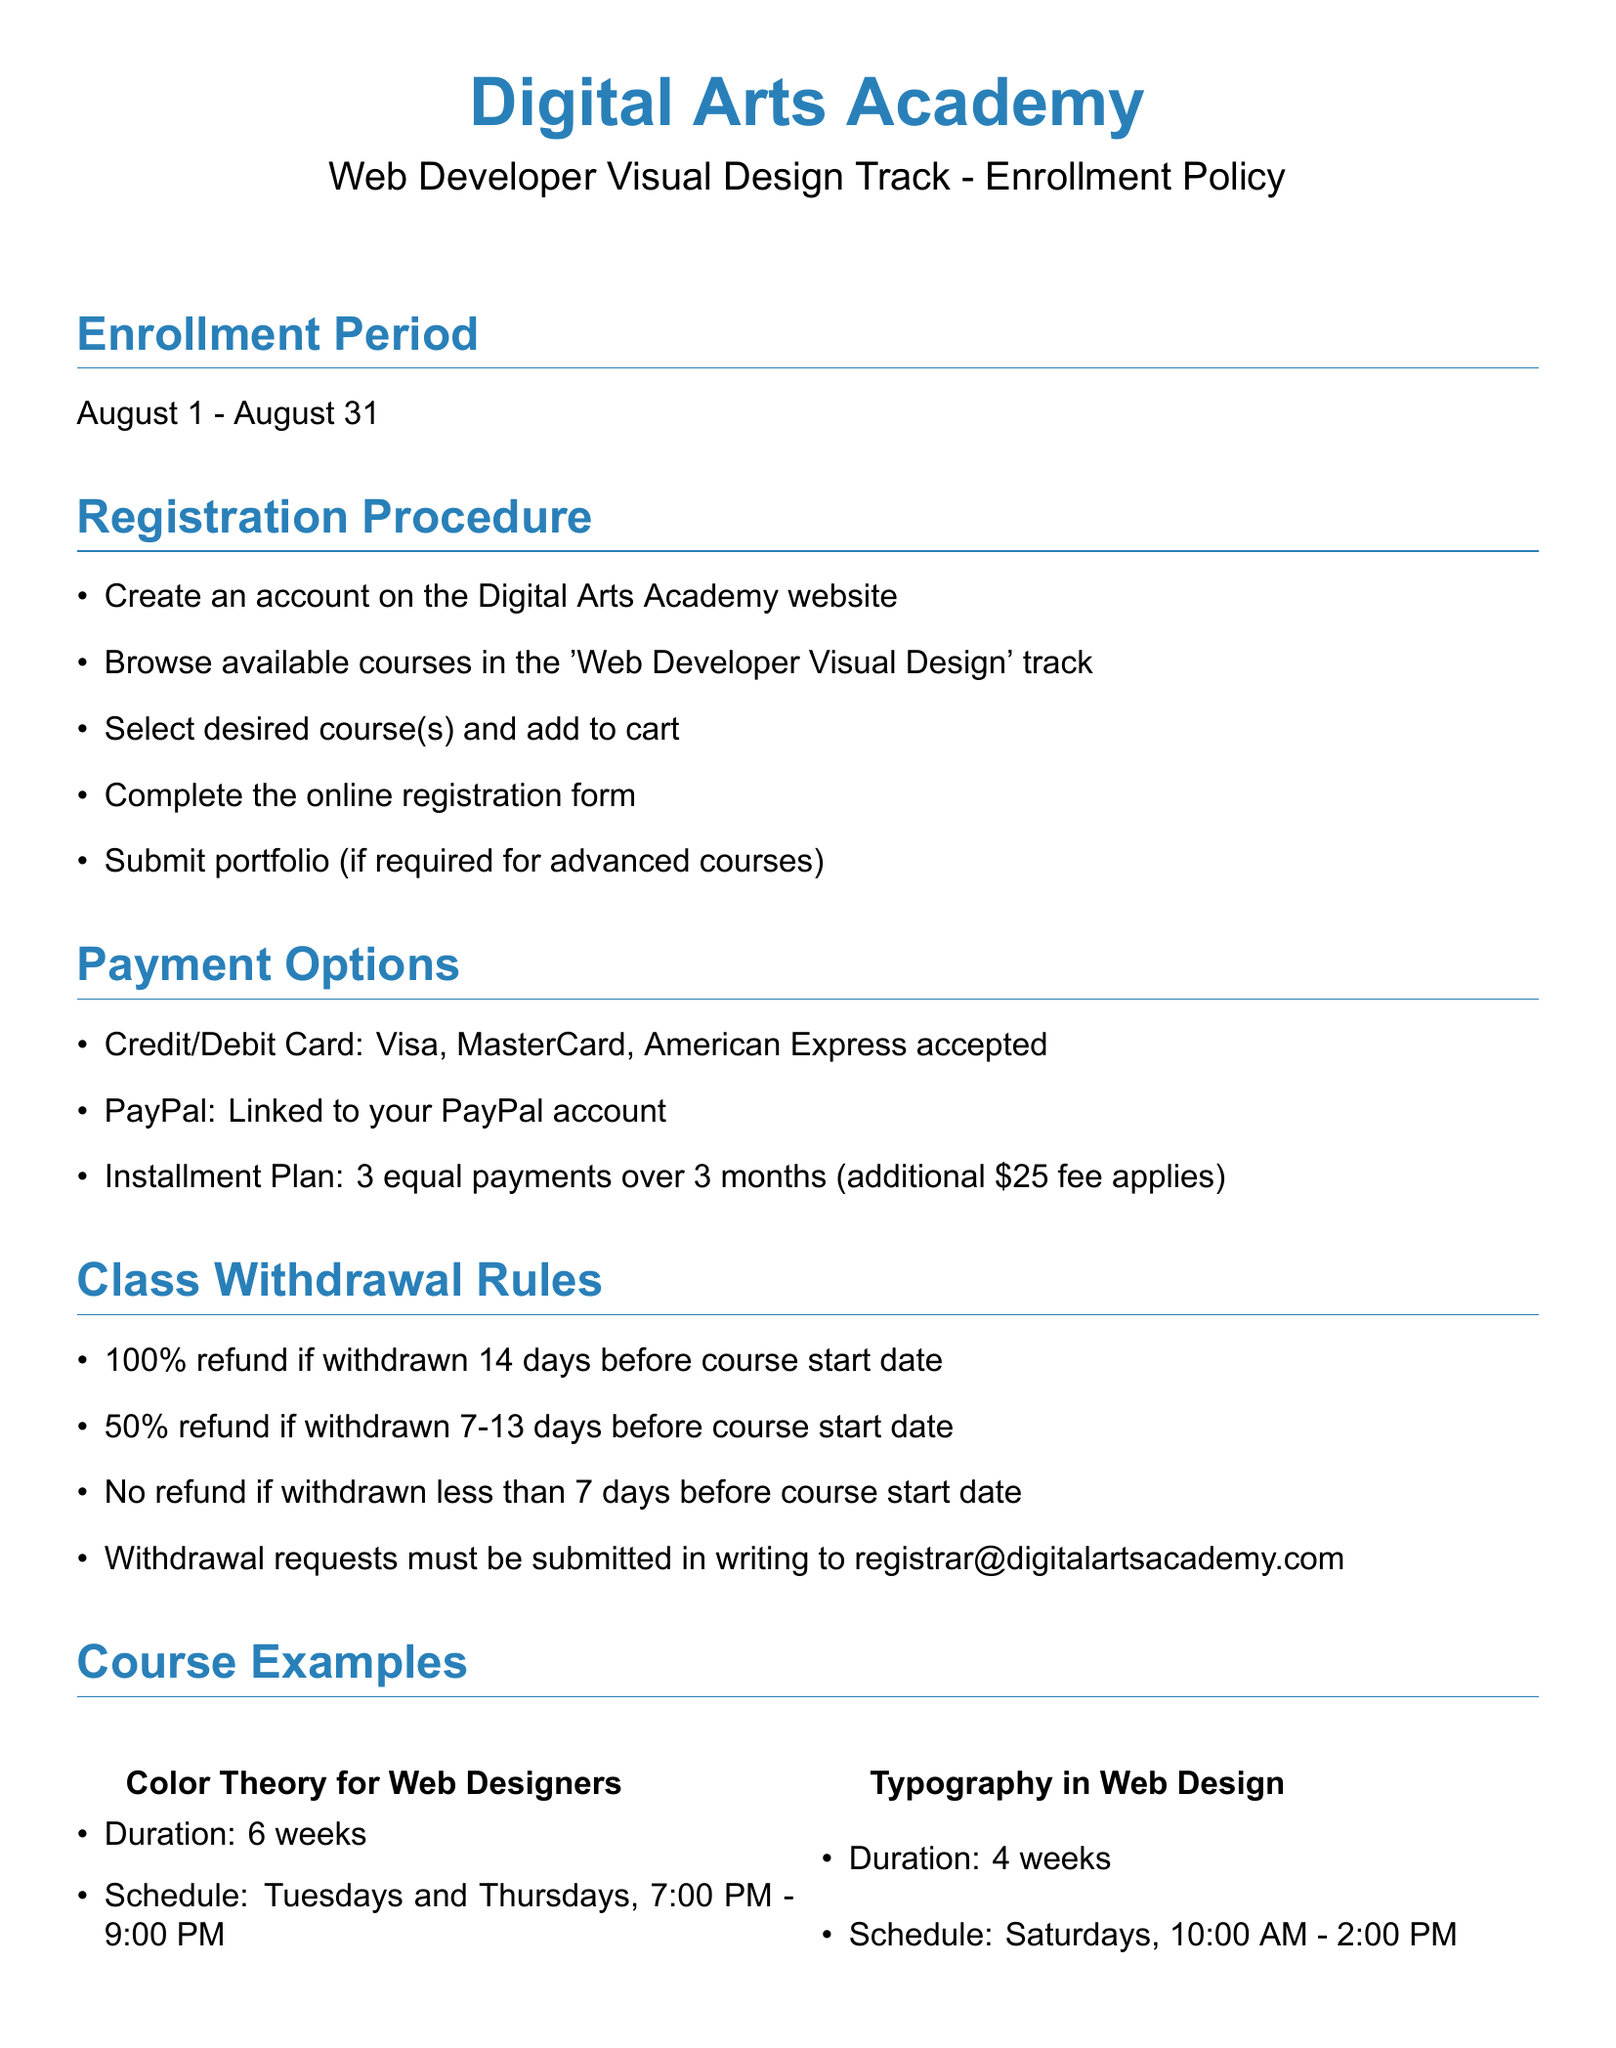What is the enrollment period? The enrollment period is clearly stated in the document, which is from August 1 to August 31.
Answer: August 1 - August 31 What payment option incurs an additional fee? The payment option for installments mentions an additional fee of $25, as noted in the document.
Answer: Installment Plan How many weeks is the "Color Theory for Web Designers" course? The duration of the "Color Theory for Web Designers" course is specified in the course examples section.
Answer: 6 weeks What percentage of the refund is available for withdrawal less than 7 days before the course starts? The document outlines the refund percentages based on withdrawal timing, stating no refund for withdrawals under 7 days.
Answer: No refund Where can withdrawal requests be submitted? The document specifies the contact method for withdrawal requests, which must be in writing sent to a particular email address.
Answer: registrar@digitalartsacademy.com How many courses are listed as examples in the document? The document contains two courses listed as examples in the course examples section.
Answer: 2 courses What is the required software for the course? The required materials state that a laptop with Adobe Creative Suite is necessary for the course.
Answer: Adobe Creative Suite What is the scheduled time for the "Typography in Web Design" course? The course schedule for "Typography in Web Design" is detailed in the document.
Answer: Saturdays, 10:00 AM - 2:00 PM 